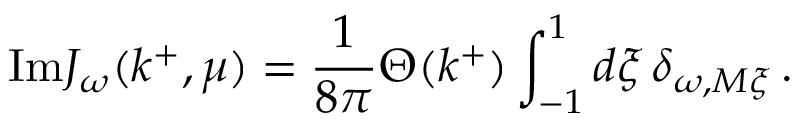Convert formula to latex. <formula><loc_0><loc_0><loc_500><loc_500>I m J _ { \omega } ( k ^ { + } , \mu ) = \frac { 1 } { 8 \pi } \Theta ( k ^ { + } ) \int _ { - 1 } ^ { 1 } d \xi \, \delta _ { \omega , M \xi } \, .</formula> 